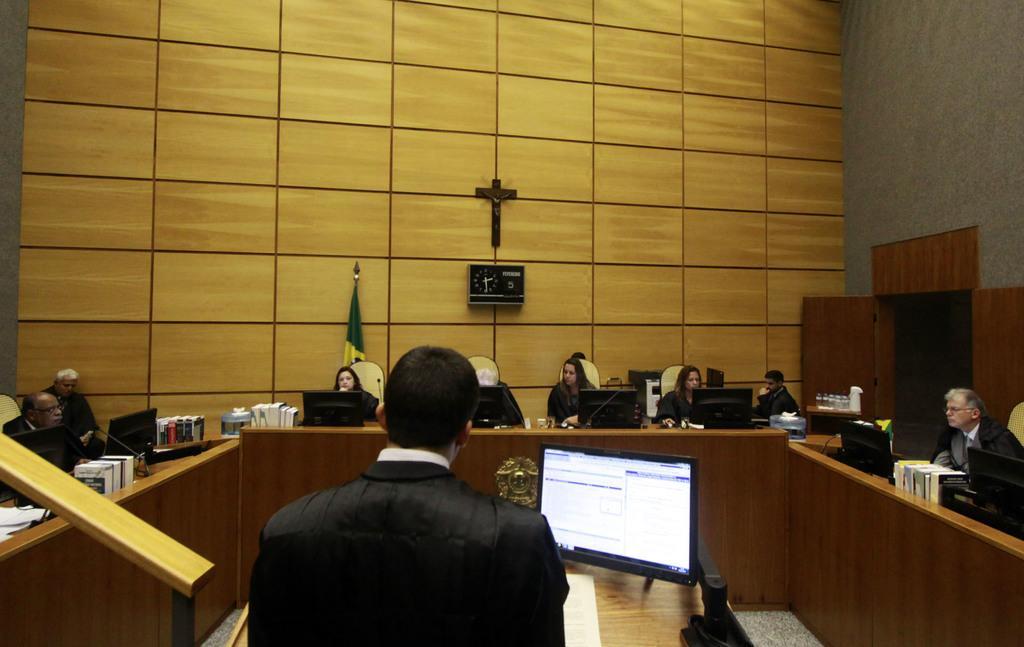In one or two sentences, can you explain what this image depicts? This picture is clicked inside. In the foreground there is a person and we can see a wooden table on the top of which a monitor and an object is placed. In the center we can see the wooden tables on the top of which monitors, books and many other objects are placed. In the background we can see the wall, sculpture and a clock hanging on the wall and we can see the wooden doors and we can see a flag and we can see the group of persons sitting on the chairs. 